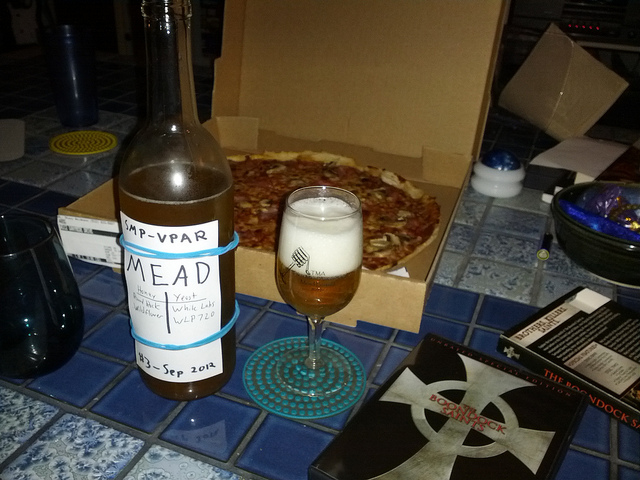Please transcribe the text information in this image. MEAD SMP VPAR 2012 sep DOCK THE THE WLA 720 